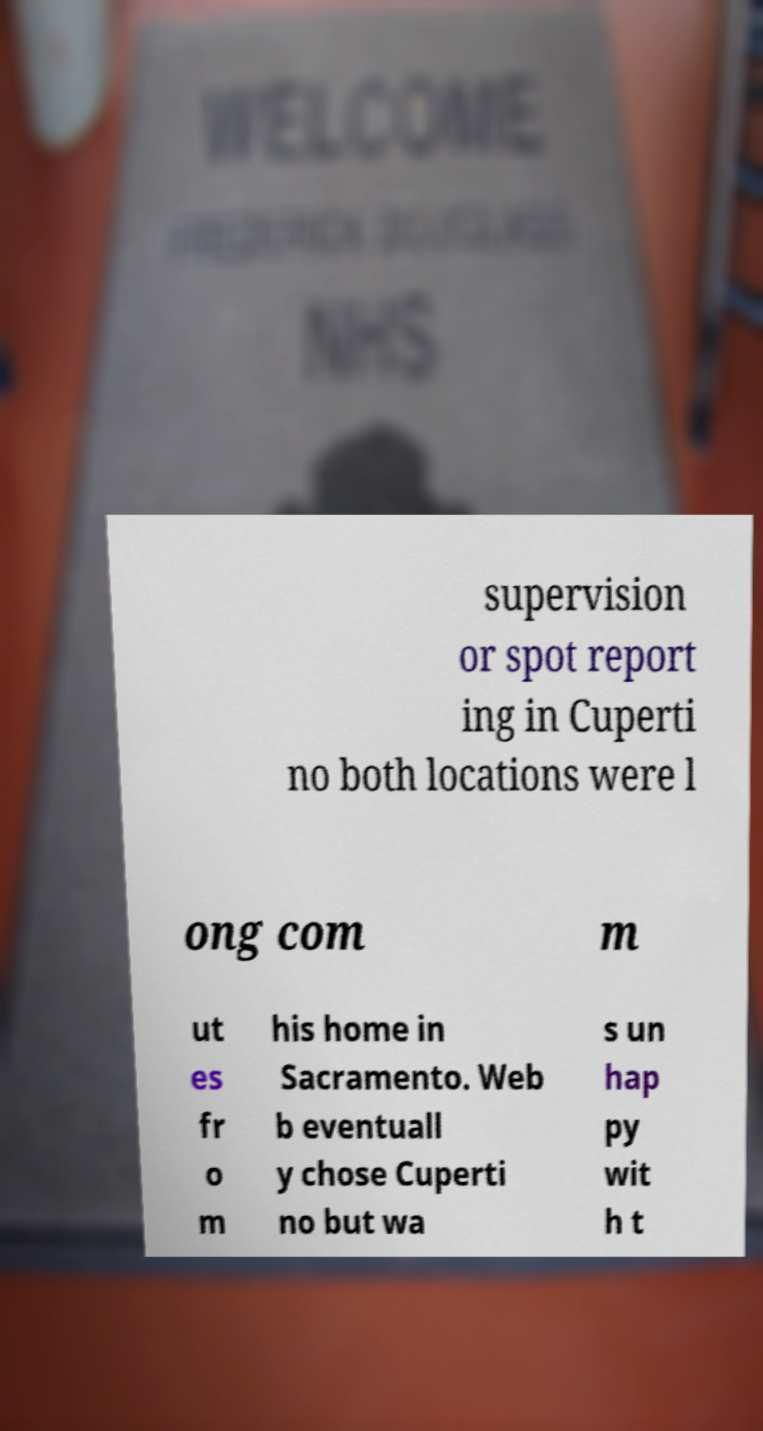Can you accurately transcribe the text from the provided image for me? supervision or spot report ing in Cuperti no both locations were l ong com m ut es fr o m his home in Sacramento. Web b eventuall y chose Cuperti no but wa s un hap py wit h t 